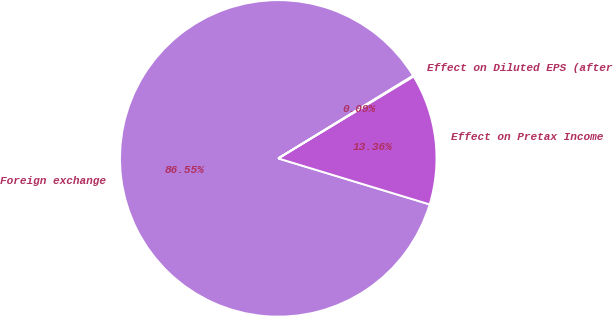Convert chart. <chart><loc_0><loc_0><loc_500><loc_500><pie_chart><fcel>Foreign exchange<fcel>Effect on Pretax Income<fcel>Effect on Diluted EPS (after<nl><fcel>86.54%<fcel>13.36%<fcel>0.09%<nl></chart> 